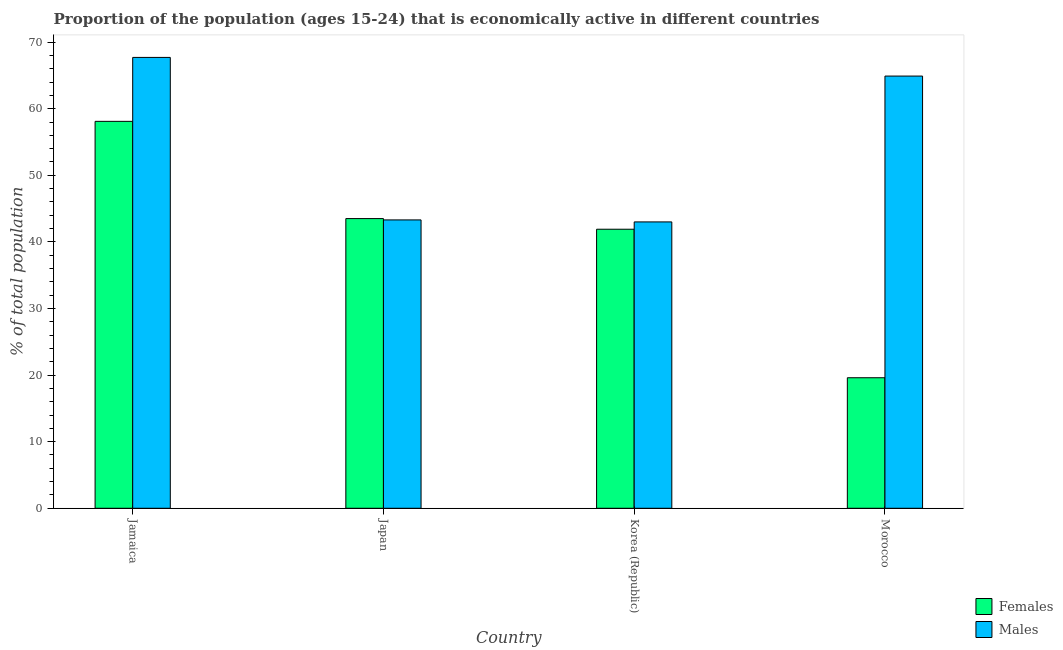Are the number of bars per tick equal to the number of legend labels?
Keep it short and to the point. Yes. Are the number of bars on each tick of the X-axis equal?
Your response must be concise. Yes. How many bars are there on the 2nd tick from the left?
Your answer should be compact. 2. What is the percentage of economically active male population in Japan?
Keep it short and to the point. 43.3. Across all countries, what is the maximum percentage of economically active male population?
Your answer should be very brief. 67.7. Across all countries, what is the minimum percentage of economically active male population?
Provide a short and direct response. 43. In which country was the percentage of economically active female population maximum?
Your answer should be very brief. Jamaica. What is the total percentage of economically active female population in the graph?
Offer a terse response. 163.1. What is the difference between the percentage of economically active male population in Jamaica and that in Korea (Republic)?
Your answer should be compact. 24.7. What is the difference between the percentage of economically active female population in Korea (Republic) and the percentage of economically active male population in Morocco?
Ensure brevity in your answer.  -23. What is the average percentage of economically active male population per country?
Provide a succinct answer. 54.72. What is the difference between the percentage of economically active female population and percentage of economically active male population in Japan?
Your answer should be compact. 0.2. In how many countries, is the percentage of economically active male population greater than 66 %?
Give a very brief answer. 1. What is the ratio of the percentage of economically active male population in Jamaica to that in Japan?
Your answer should be compact. 1.56. Is the percentage of economically active male population in Japan less than that in Morocco?
Offer a very short reply. Yes. Is the difference between the percentage of economically active male population in Korea (Republic) and Morocco greater than the difference between the percentage of economically active female population in Korea (Republic) and Morocco?
Your response must be concise. No. What is the difference between the highest and the second highest percentage of economically active male population?
Ensure brevity in your answer.  2.8. What is the difference between the highest and the lowest percentage of economically active male population?
Ensure brevity in your answer.  24.7. Is the sum of the percentage of economically active female population in Jamaica and Morocco greater than the maximum percentage of economically active male population across all countries?
Your response must be concise. Yes. What does the 1st bar from the left in Korea (Republic) represents?
Make the answer very short. Females. What does the 2nd bar from the right in Japan represents?
Your answer should be very brief. Females. How many countries are there in the graph?
Offer a very short reply. 4. What is the difference between two consecutive major ticks on the Y-axis?
Give a very brief answer. 10. How many legend labels are there?
Provide a short and direct response. 2. What is the title of the graph?
Ensure brevity in your answer.  Proportion of the population (ages 15-24) that is economically active in different countries. What is the label or title of the Y-axis?
Give a very brief answer. % of total population. What is the % of total population in Females in Jamaica?
Your answer should be very brief. 58.1. What is the % of total population of Males in Jamaica?
Provide a short and direct response. 67.7. What is the % of total population in Females in Japan?
Provide a succinct answer. 43.5. What is the % of total population of Males in Japan?
Your response must be concise. 43.3. What is the % of total population of Females in Korea (Republic)?
Offer a terse response. 41.9. What is the % of total population in Females in Morocco?
Your answer should be compact. 19.6. What is the % of total population of Males in Morocco?
Offer a terse response. 64.9. Across all countries, what is the maximum % of total population in Females?
Ensure brevity in your answer.  58.1. Across all countries, what is the maximum % of total population in Males?
Give a very brief answer. 67.7. Across all countries, what is the minimum % of total population of Females?
Give a very brief answer. 19.6. What is the total % of total population of Females in the graph?
Make the answer very short. 163.1. What is the total % of total population in Males in the graph?
Make the answer very short. 218.9. What is the difference between the % of total population in Females in Jamaica and that in Japan?
Provide a short and direct response. 14.6. What is the difference between the % of total population of Males in Jamaica and that in Japan?
Your answer should be very brief. 24.4. What is the difference between the % of total population in Females in Jamaica and that in Korea (Republic)?
Give a very brief answer. 16.2. What is the difference between the % of total population in Males in Jamaica and that in Korea (Republic)?
Your answer should be compact. 24.7. What is the difference between the % of total population in Females in Jamaica and that in Morocco?
Keep it short and to the point. 38.5. What is the difference between the % of total population of Males in Jamaica and that in Morocco?
Your response must be concise. 2.8. What is the difference between the % of total population in Females in Japan and that in Korea (Republic)?
Your response must be concise. 1.6. What is the difference between the % of total population in Males in Japan and that in Korea (Republic)?
Keep it short and to the point. 0.3. What is the difference between the % of total population of Females in Japan and that in Morocco?
Give a very brief answer. 23.9. What is the difference between the % of total population of Males in Japan and that in Morocco?
Offer a very short reply. -21.6. What is the difference between the % of total population in Females in Korea (Republic) and that in Morocco?
Offer a very short reply. 22.3. What is the difference between the % of total population in Males in Korea (Republic) and that in Morocco?
Make the answer very short. -21.9. What is the difference between the % of total population of Females in Jamaica and the % of total population of Males in Japan?
Your response must be concise. 14.8. What is the difference between the % of total population of Females in Jamaica and the % of total population of Males in Korea (Republic)?
Your answer should be very brief. 15.1. What is the difference between the % of total population in Females in Jamaica and the % of total population in Males in Morocco?
Your answer should be very brief. -6.8. What is the difference between the % of total population of Females in Japan and the % of total population of Males in Korea (Republic)?
Your response must be concise. 0.5. What is the difference between the % of total population in Females in Japan and the % of total population in Males in Morocco?
Your answer should be compact. -21.4. What is the difference between the % of total population of Females in Korea (Republic) and the % of total population of Males in Morocco?
Provide a succinct answer. -23. What is the average % of total population in Females per country?
Give a very brief answer. 40.77. What is the average % of total population in Males per country?
Your answer should be compact. 54.73. What is the difference between the % of total population of Females and % of total population of Males in Jamaica?
Make the answer very short. -9.6. What is the difference between the % of total population in Females and % of total population in Males in Japan?
Provide a succinct answer. 0.2. What is the difference between the % of total population in Females and % of total population in Males in Morocco?
Give a very brief answer. -45.3. What is the ratio of the % of total population in Females in Jamaica to that in Japan?
Give a very brief answer. 1.34. What is the ratio of the % of total population in Males in Jamaica to that in Japan?
Your response must be concise. 1.56. What is the ratio of the % of total population in Females in Jamaica to that in Korea (Republic)?
Keep it short and to the point. 1.39. What is the ratio of the % of total population of Males in Jamaica to that in Korea (Republic)?
Your answer should be compact. 1.57. What is the ratio of the % of total population in Females in Jamaica to that in Morocco?
Provide a short and direct response. 2.96. What is the ratio of the % of total population in Males in Jamaica to that in Morocco?
Your answer should be compact. 1.04. What is the ratio of the % of total population in Females in Japan to that in Korea (Republic)?
Offer a very short reply. 1.04. What is the ratio of the % of total population in Males in Japan to that in Korea (Republic)?
Your response must be concise. 1.01. What is the ratio of the % of total population of Females in Japan to that in Morocco?
Your answer should be very brief. 2.22. What is the ratio of the % of total population of Males in Japan to that in Morocco?
Your answer should be compact. 0.67. What is the ratio of the % of total population of Females in Korea (Republic) to that in Morocco?
Provide a short and direct response. 2.14. What is the ratio of the % of total population in Males in Korea (Republic) to that in Morocco?
Make the answer very short. 0.66. What is the difference between the highest and the second highest % of total population of Females?
Provide a succinct answer. 14.6. What is the difference between the highest and the second highest % of total population in Males?
Make the answer very short. 2.8. What is the difference between the highest and the lowest % of total population in Females?
Give a very brief answer. 38.5. What is the difference between the highest and the lowest % of total population of Males?
Your answer should be compact. 24.7. 